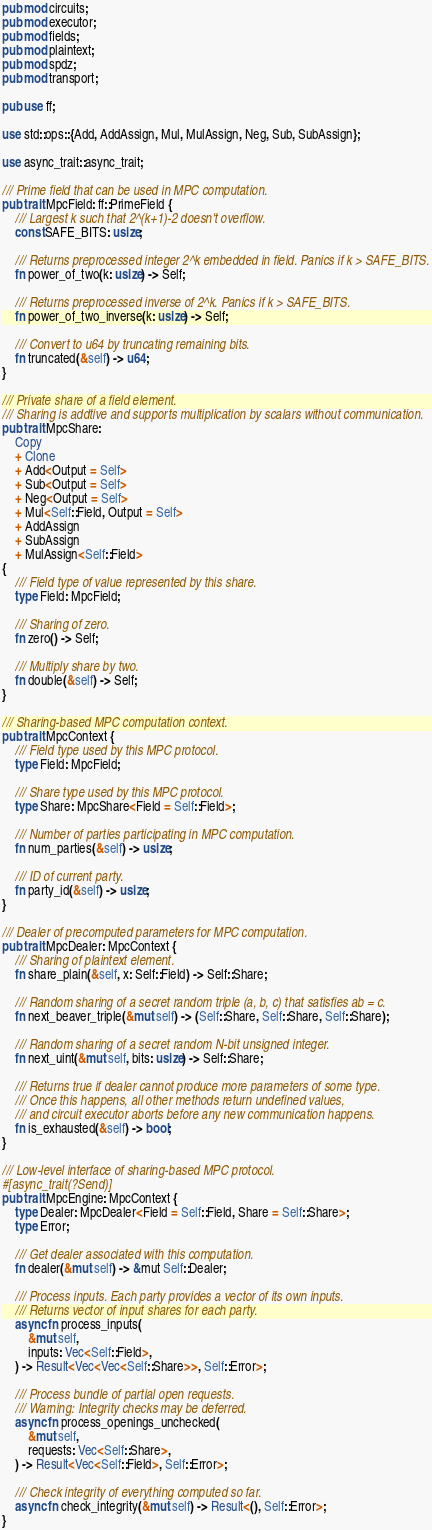Convert code to text. <code><loc_0><loc_0><loc_500><loc_500><_Rust_>pub mod circuits;
pub mod executor;
pub mod fields;
pub mod plaintext;
pub mod spdz;
pub mod transport;

pub use ff;

use std::ops::{Add, AddAssign, Mul, MulAssign, Neg, Sub, SubAssign};

use async_trait::async_trait;

/// Prime field that can be used in MPC computation.
pub trait MpcField: ff::PrimeField {
    /// Largest k such that 2^(k+1)-2 doesn't overflow.
    const SAFE_BITS: usize;

    /// Returns preprocessed integer 2^k embedded in field. Panics if k > SAFE_BITS.
    fn power_of_two(k: usize) -> Self;

    /// Returns preprocessed inverse of 2^k. Panics if k > SAFE_BITS.
    fn power_of_two_inverse(k: usize) -> Self;

    /// Convert to u64 by truncating remaining bits.
    fn truncated(&self) -> u64;
}

/// Private share of a field element.
/// Sharing is addtive and supports multiplication by scalars without communication.
pub trait MpcShare:
    Copy
    + Clone
    + Add<Output = Self>
    + Sub<Output = Self>
    + Neg<Output = Self>
    + Mul<Self::Field, Output = Self>
    + AddAssign
    + SubAssign
    + MulAssign<Self::Field>
{
    /// Field type of value represented by this share.
    type Field: MpcField;

    /// Sharing of zero.
    fn zero() -> Self;

    /// Multiply share by two.
    fn double(&self) -> Self;
}

/// Sharing-based MPC computation context.
pub trait MpcContext {
    /// Field type used by this MPC protocol.
    type Field: MpcField;

    /// Share type used by this MPC protocol.
    type Share: MpcShare<Field = Self::Field>;

    /// Number of parties participating in MPC computation.
    fn num_parties(&self) -> usize;

    /// ID of current party.
    fn party_id(&self) -> usize;
}

/// Dealer of precomputed parameters for MPC computation.
pub trait MpcDealer: MpcContext {
    /// Sharing of plaintext element.
    fn share_plain(&self, x: Self::Field) -> Self::Share;

    /// Random sharing of a secret random triple (a, b, c) that satisfies ab = c.
    fn next_beaver_triple(&mut self) -> (Self::Share, Self::Share, Self::Share);

    /// Random sharing of a secret random N-bit unsigned integer.
    fn next_uint(&mut self, bits: usize) -> Self::Share;

    /// Returns true if dealer cannot produce more parameters of some type.
    /// Once this happens, all other methods return undefined values,
    /// and circuit executor aborts before any new communication happens.
    fn is_exhausted(&self) -> bool;
}

/// Low-level interface of sharing-based MPC protocol.
#[async_trait(?Send)]
pub trait MpcEngine: MpcContext {
    type Dealer: MpcDealer<Field = Self::Field, Share = Self::Share>;
    type Error;

    /// Get dealer associated with this computation.
    fn dealer(&mut self) -> &mut Self::Dealer;

    /// Process inputs. Each party provides a vector of its own inputs.
    /// Returns vector of input shares for each party.
    async fn process_inputs(
        &mut self,
        inputs: Vec<Self::Field>,
    ) -> Result<Vec<Vec<Self::Share>>, Self::Error>;

    /// Process bundle of partial open requests.
    /// Warning: Integrity checks may be deferred.
    async fn process_openings_unchecked(
        &mut self,
        requests: Vec<Self::Share>,
    ) -> Result<Vec<Self::Field>, Self::Error>;

    /// Check integrity of everything computed so far.
    async fn check_integrity(&mut self) -> Result<(), Self::Error>;
}
</code> 